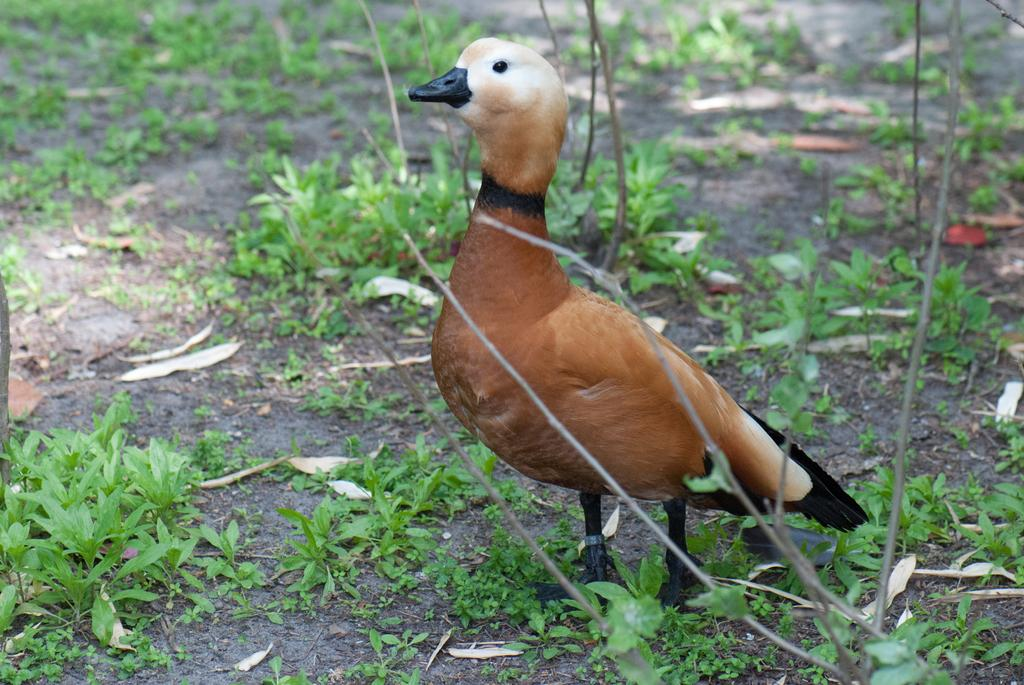What type of animal is in the image? There is a duck in the image. What color is the duck? The duck is colored brown. What can be seen on the ground in the image? There are plants on the ground in the image. Can you see the duck giving a kiss to its sister in the image? There is no duck giving a kiss to its sister in the image, as the provided facts do not mention any interaction between the duck and a sister. 